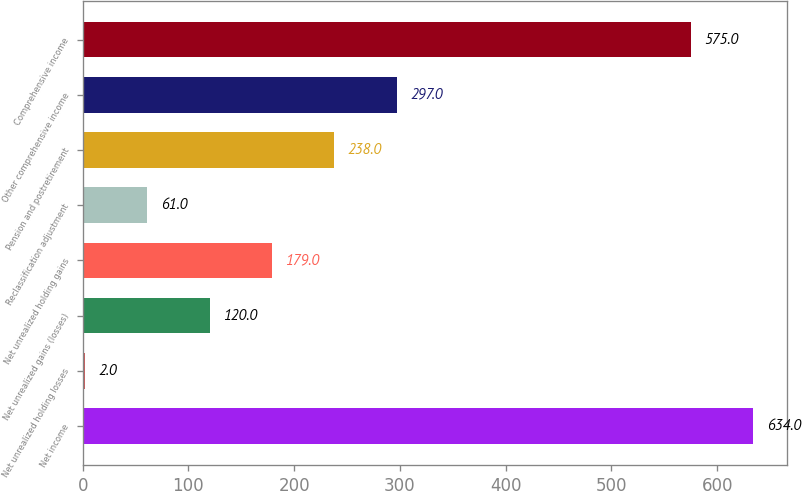Convert chart. <chart><loc_0><loc_0><loc_500><loc_500><bar_chart><fcel>Net income<fcel>Net unrealized holding losses<fcel>Net unrealized gains (losses)<fcel>Net unrealized holding gains<fcel>Reclassification adjustment<fcel>Pension and postretirement<fcel>Other comprehensive income<fcel>Comprehensive income<nl><fcel>634<fcel>2<fcel>120<fcel>179<fcel>61<fcel>238<fcel>297<fcel>575<nl></chart> 